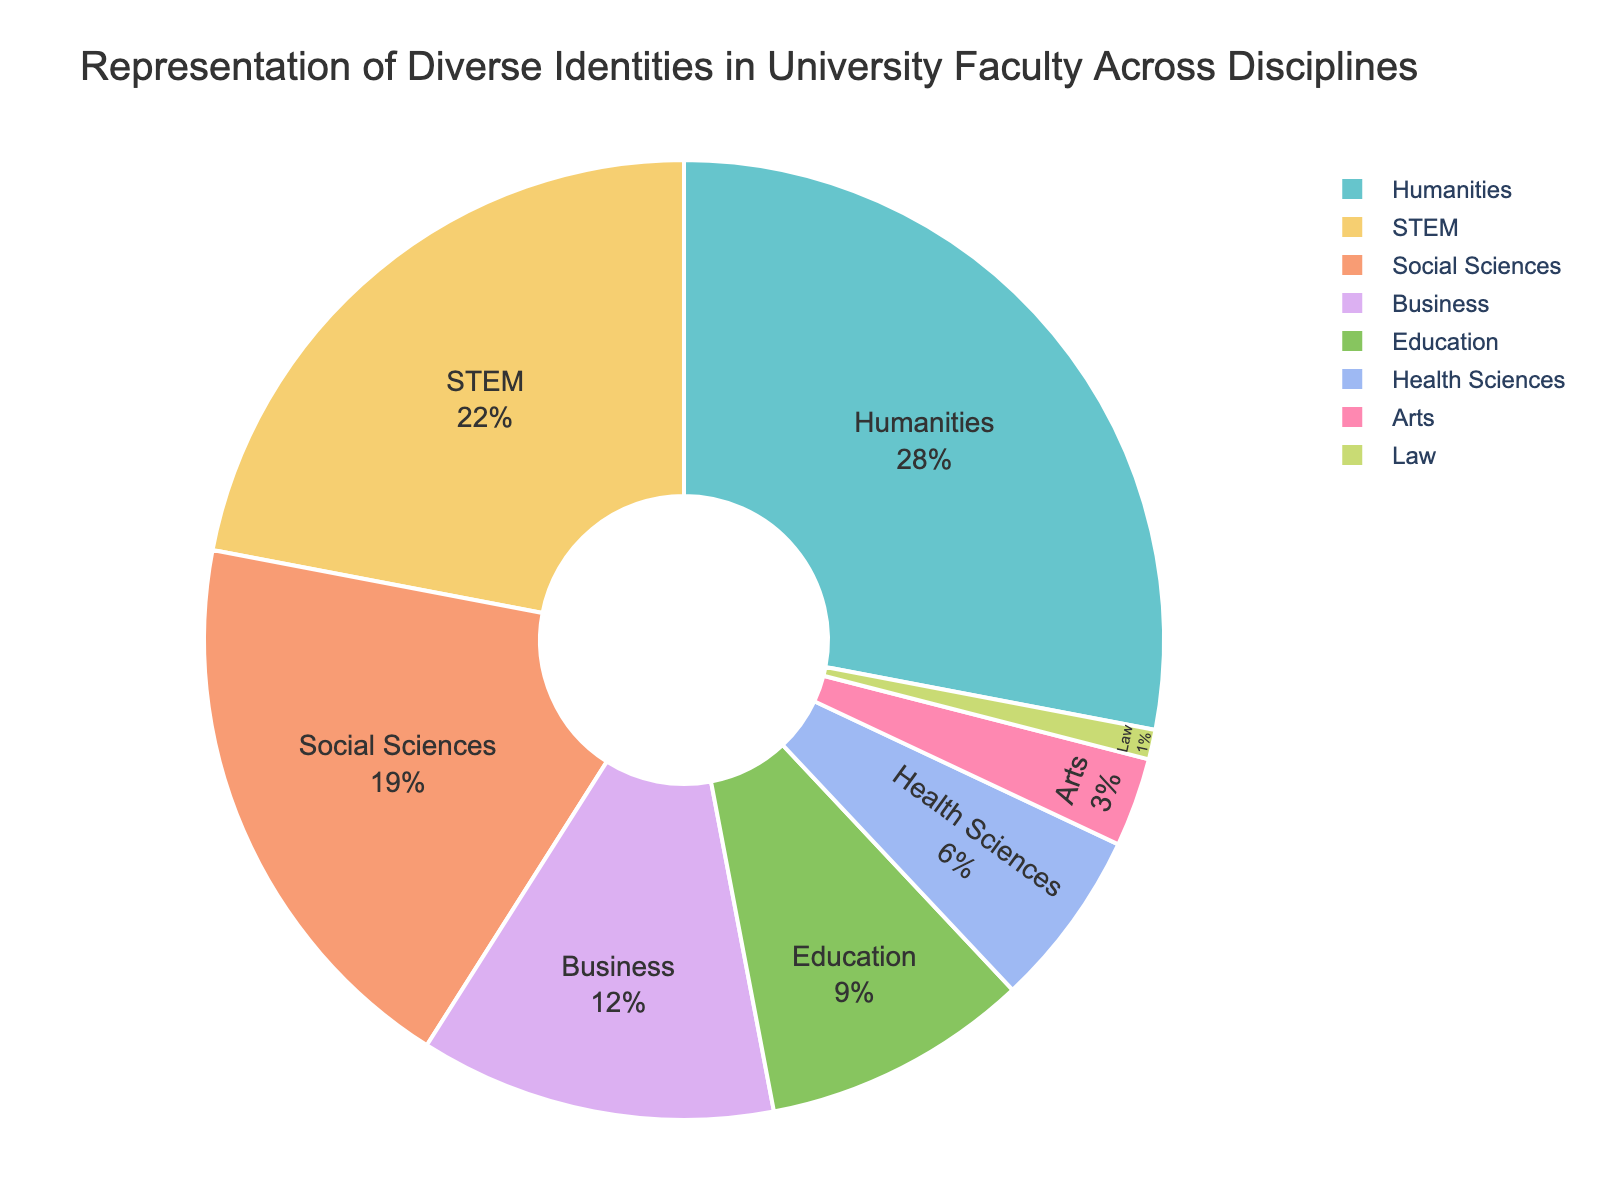Which discipline has the highest representation? The discipline with the highest percentage slice in the pie chart represents the highest representation.
Answer: Humanities Which two disciplines together account for more than half of the faculty representation? Summing the percentages of the top two disciplines, Humanities (28%) and STEM (22%), gives 50%, which is exactly half of the total representation.
Answer: Humanities and STEM How does the representation of Social Sciences compare to that of Business? According to the pie chart, Social Sciences represent 19%, while Business represents 12%, indicating Social Sciences has a higher representation.
Answer: Social Sciences have a higher representation than Business What fraction of the total representation is attributed to Health Sciences and Arts combined? Adding the percentages for Health Sciences (6%) and Arts (3%), we get a total of 9%, which is a fraction 9/100 or simplified to 9%.
Answer: 9% What is the difference in representation between the most and least represented disciplines? The most represented discipline is Humanities (28%) and the least represented is Law (1%). The difference is 28% - 1% = 27%.
Answer: 27% Which disciplines have less than 10% representation? According to the pie chart, Health Sciences (6%), Arts (3%), and Law (1%) each have less than 10% representation.
Answer: Health Sciences, Arts, and Law What proportion of the faculty is represented by the combined percentage of STEM and Education disciplines? Adding the percentages for STEM (22%) and Education (9%), the combined representation is 31%.
Answer: 31% If you combine the representation of all disciplines with more than 20%, what is their total contribution? Only Humanities (28%) and STEM (22%) have more than 20%. Adding them together gives a total contribution of 50%.
Answer: 50% Which discipline has a representation closest to 5%? The pie chart shows that Health Sciences have a representation of 6%, which is closest to 5%.
Answer: Health Sciences How many disciplines have a lower representation than Education? According to the pie chart, Arts (3%), Law (1%), and Health Sciences (6%), totaling three disciplines, have a lower representation than Education (9%).
Answer: 3 